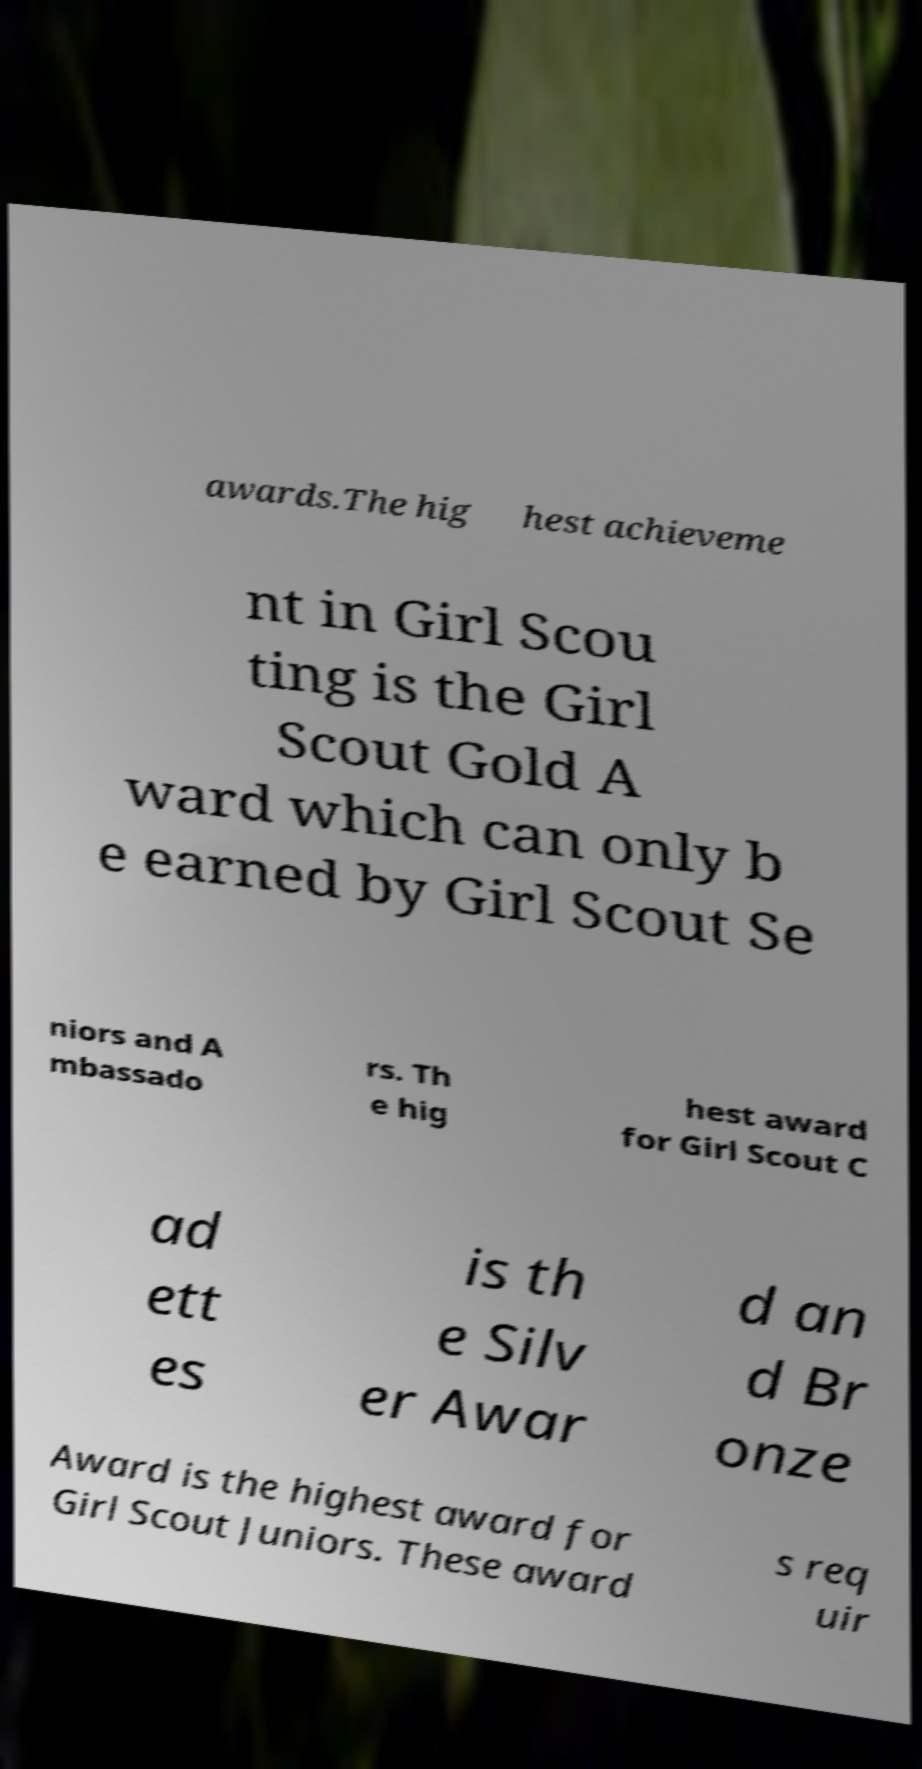For documentation purposes, I need the text within this image transcribed. Could you provide that? awards.The hig hest achieveme nt in Girl Scou ting is the Girl Scout Gold A ward which can only b e earned by Girl Scout Se niors and A mbassado rs. Th e hig hest award for Girl Scout C ad ett es is th e Silv er Awar d an d Br onze Award is the highest award for Girl Scout Juniors. These award s req uir 